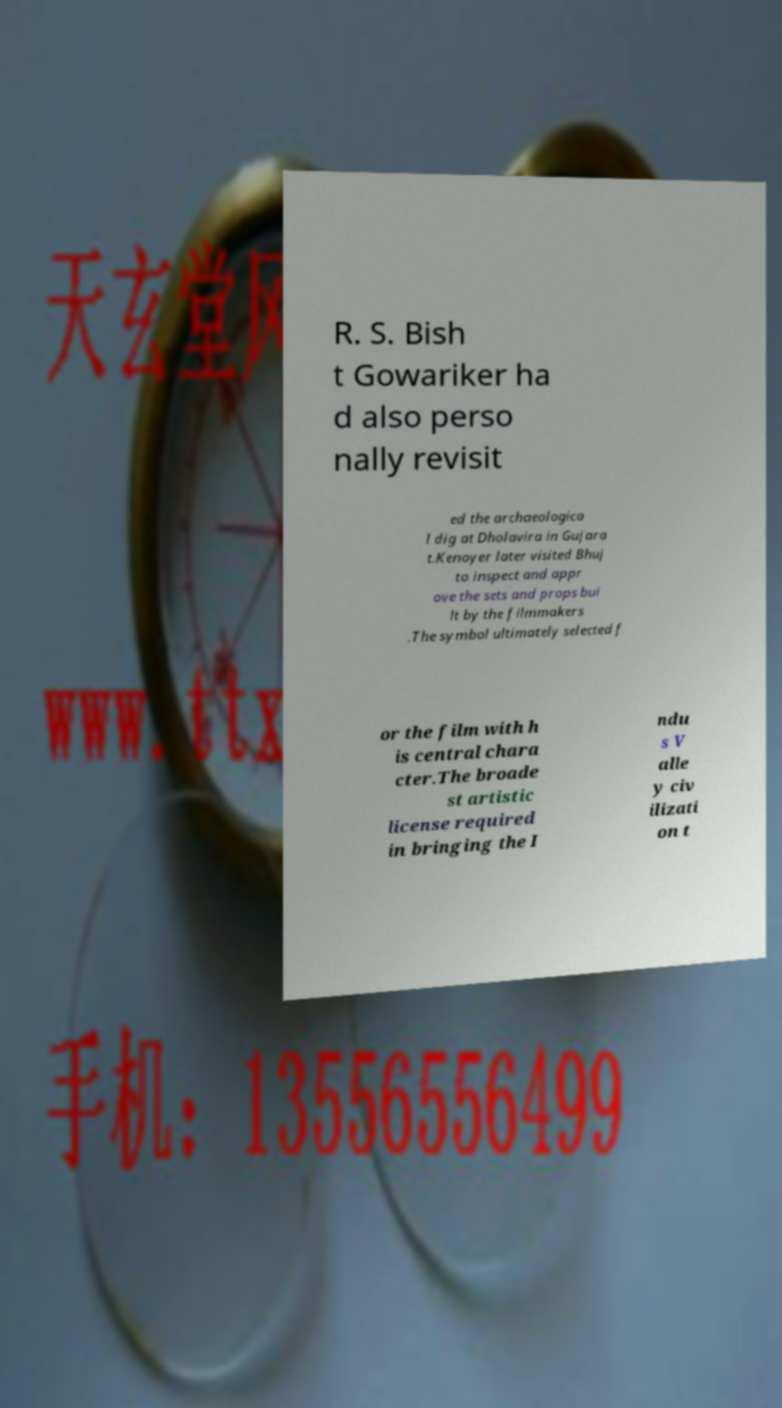Please read and relay the text visible in this image. What does it say? R. S. Bish t Gowariker ha d also perso nally revisit ed the archaeologica l dig at Dholavira in Gujara t.Kenoyer later visited Bhuj to inspect and appr ove the sets and props bui lt by the filmmakers .The symbol ultimately selected f or the film with h is central chara cter.The broade st artistic license required in bringing the I ndu s V alle y civ ilizati on t 